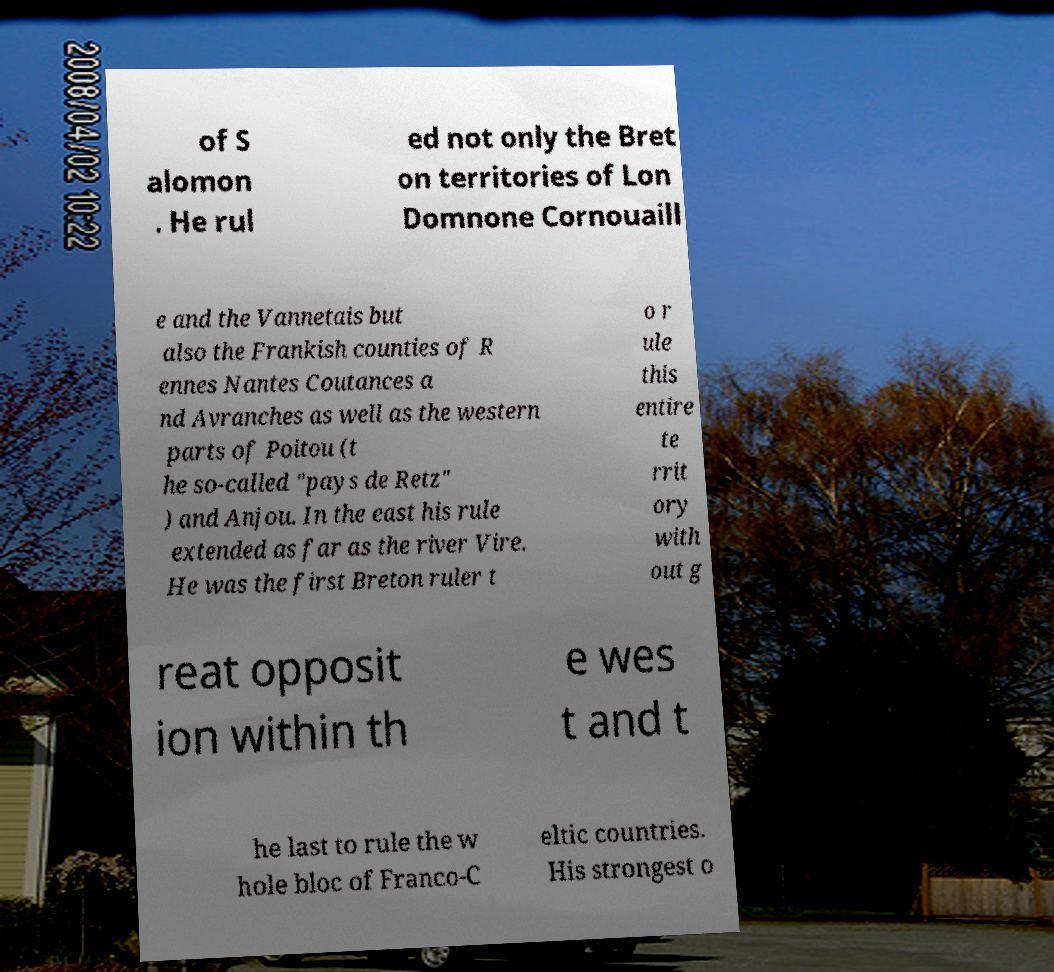Can you read and provide the text displayed in the image?This photo seems to have some interesting text. Can you extract and type it out for me? of S alomon . He rul ed not only the Bret on territories of Lon Domnone Cornouaill e and the Vannetais but also the Frankish counties of R ennes Nantes Coutances a nd Avranches as well as the western parts of Poitou (t he so-called "pays de Retz" ) and Anjou. In the east his rule extended as far as the river Vire. He was the first Breton ruler t o r ule this entire te rrit ory with out g reat opposit ion within th e wes t and t he last to rule the w hole bloc of Franco-C eltic countries. His strongest o 